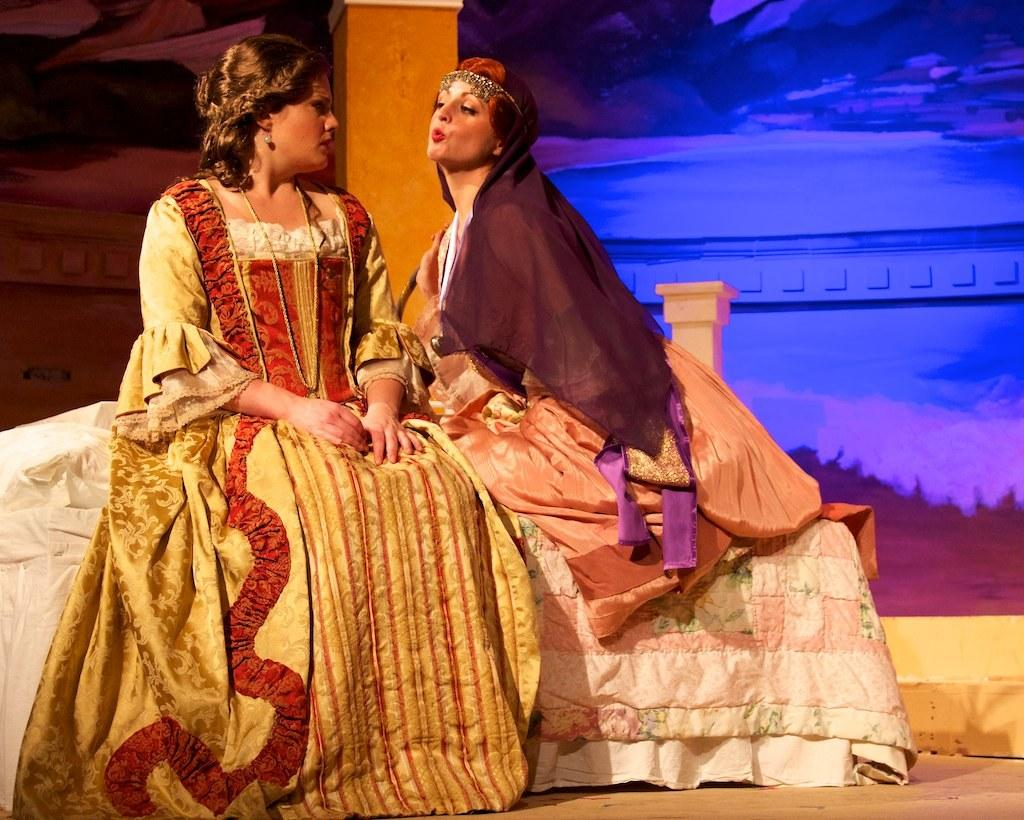How many people are in the image? There are two women in the image. What are the women doing in the image? The women are sitting on a platform. What can be seen in the background of the image? There is a pillar in the background of the image. What type of harmony is being played by the women in the image? There is no indication of music or harmony in the image; the women are simply sitting on a platform. 